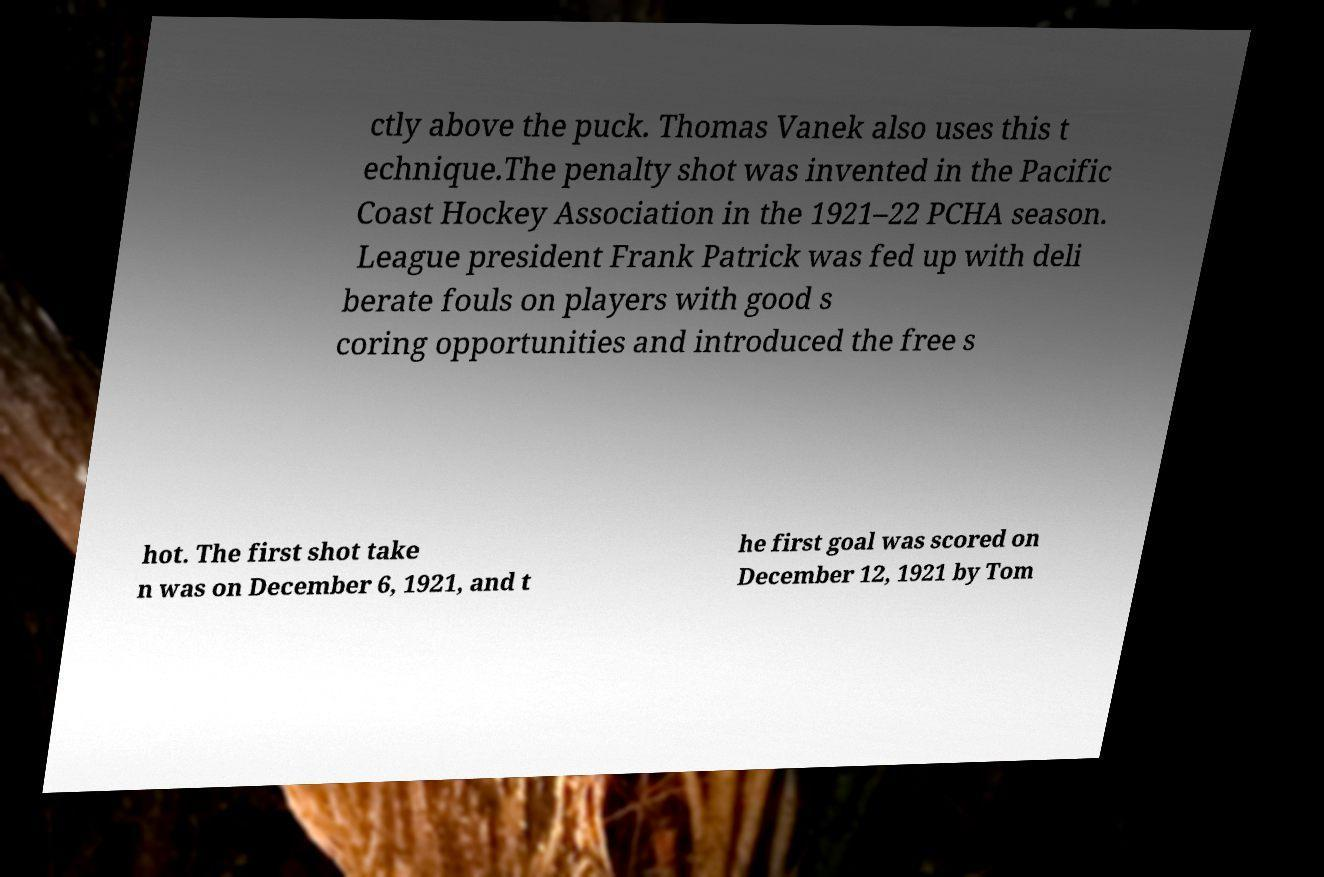Could you assist in decoding the text presented in this image and type it out clearly? ctly above the puck. Thomas Vanek also uses this t echnique.The penalty shot was invented in the Pacific Coast Hockey Association in the 1921–22 PCHA season. League president Frank Patrick was fed up with deli berate fouls on players with good s coring opportunities and introduced the free s hot. The first shot take n was on December 6, 1921, and t he first goal was scored on December 12, 1921 by Tom 